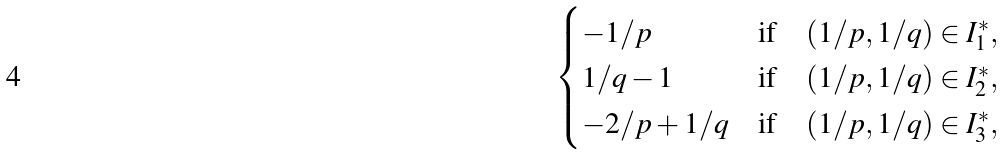Convert formula to latex. <formula><loc_0><loc_0><loc_500><loc_500>\begin{cases} - 1 / p & \text {if} \quad ( 1 / p , 1 / q ) \in I _ { 1 } ^ { * } , \\ 1 / q - 1 & \text {if} \quad ( 1 / p , 1 / q ) \in I _ { 2 } ^ { * } , \\ - 2 / p + 1 / q & \text {if} \quad ( 1 / p , 1 / q ) \in I _ { 3 } ^ { * } , \end{cases}</formula> 